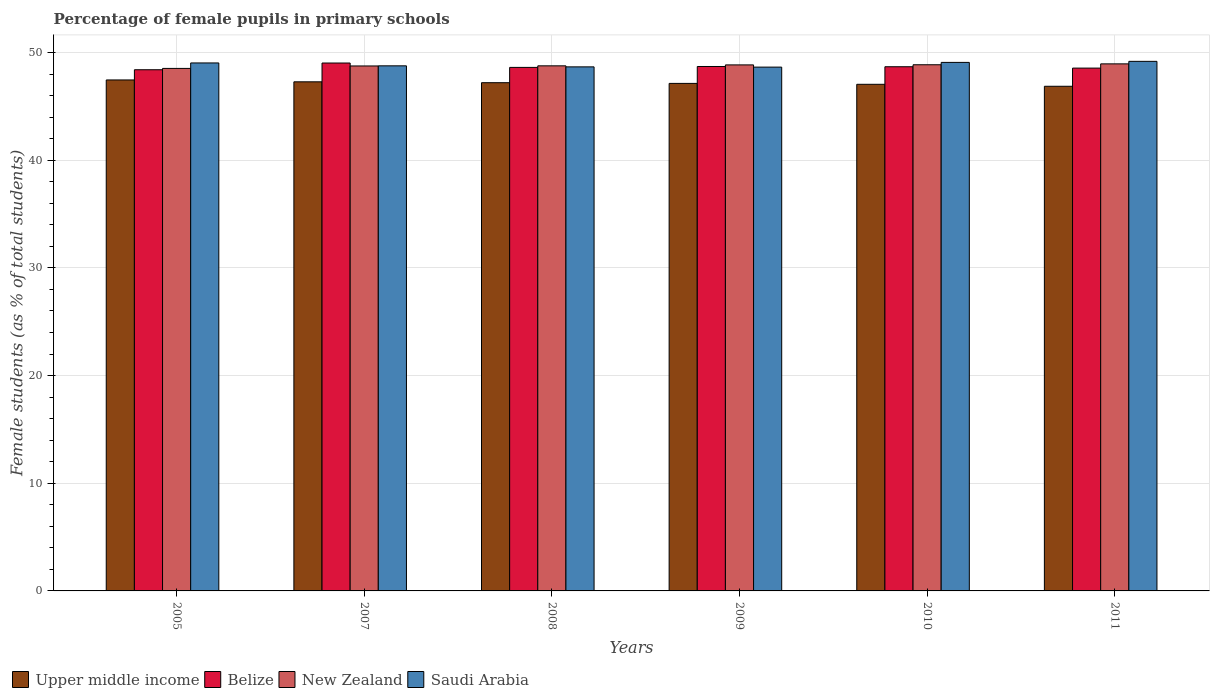Are the number of bars on each tick of the X-axis equal?
Give a very brief answer. Yes. How many bars are there on the 1st tick from the right?
Your response must be concise. 4. What is the label of the 5th group of bars from the left?
Keep it short and to the point. 2010. In how many cases, is the number of bars for a given year not equal to the number of legend labels?
Provide a short and direct response. 0. What is the percentage of female pupils in primary schools in New Zealand in 2008?
Your answer should be very brief. 48.76. Across all years, what is the maximum percentage of female pupils in primary schools in Saudi Arabia?
Your answer should be very brief. 49.18. Across all years, what is the minimum percentage of female pupils in primary schools in Saudi Arabia?
Make the answer very short. 48.64. In which year was the percentage of female pupils in primary schools in Saudi Arabia maximum?
Ensure brevity in your answer.  2011. What is the total percentage of female pupils in primary schools in Belize in the graph?
Ensure brevity in your answer.  291.96. What is the difference between the percentage of female pupils in primary schools in Saudi Arabia in 2009 and that in 2011?
Offer a terse response. -0.54. What is the difference between the percentage of female pupils in primary schools in Belize in 2011 and the percentage of female pupils in primary schools in Upper middle income in 2009?
Your answer should be compact. 1.42. What is the average percentage of female pupils in primary schools in Saudi Arabia per year?
Your answer should be very brief. 48.89. In the year 2009, what is the difference between the percentage of female pupils in primary schools in Upper middle income and percentage of female pupils in primary schools in Saudi Arabia?
Your answer should be compact. -1.51. What is the ratio of the percentage of female pupils in primary schools in Belize in 2005 to that in 2009?
Provide a succinct answer. 0.99. What is the difference between the highest and the second highest percentage of female pupils in primary schools in Saudi Arabia?
Offer a very short reply. 0.1. What is the difference between the highest and the lowest percentage of female pupils in primary schools in Upper middle income?
Your answer should be very brief. 0.59. In how many years, is the percentage of female pupils in primary schools in Saudi Arabia greater than the average percentage of female pupils in primary schools in Saudi Arabia taken over all years?
Provide a short and direct response. 3. What does the 4th bar from the left in 2005 represents?
Provide a short and direct response. Saudi Arabia. What does the 2nd bar from the right in 2009 represents?
Your response must be concise. New Zealand. Is it the case that in every year, the sum of the percentage of female pupils in primary schools in New Zealand and percentage of female pupils in primary schools in Belize is greater than the percentage of female pupils in primary schools in Upper middle income?
Provide a succinct answer. Yes. Are all the bars in the graph horizontal?
Your answer should be compact. No. How many legend labels are there?
Provide a short and direct response. 4. How are the legend labels stacked?
Your answer should be compact. Horizontal. What is the title of the graph?
Offer a terse response. Percentage of female pupils in primary schools. Does "Iceland" appear as one of the legend labels in the graph?
Your answer should be very brief. No. What is the label or title of the X-axis?
Give a very brief answer. Years. What is the label or title of the Y-axis?
Offer a very short reply. Female students (as % of total students). What is the Female students (as % of total students) of Upper middle income in 2005?
Your response must be concise. 47.45. What is the Female students (as % of total students) in Belize in 2005?
Offer a terse response. 48.4. What is the Female students (as % of total students) in New Zealand in 2005?
Offer a terse response. 48.52. What is the Female students (as % of total students) of Saudi Arabia in 2005?
Your response must be concise. 49.03. What is the Female students (as % of total students) in Upper middle income in 2007?
Ensure brevity in your answer.  47.28. What is the Female students (as % of total students) of Belize in 2007?
Offer a terse response. 49.02. What is the Female students (as % of total students) of New Zealand in 2007?
Offer a terse response. 48.75. What is the Female students (as % of total students) in Saudi Arabia in 2007?
Your answer should be very brief. 48.76. What is the Female students (as % of total students) of Upper middle income in 2008?
Keep it short and to the point. 47.19. What is the Female students (as % of total students) of Belize in 2008?
Ensure brevity in your answer.  48.62. What is the Female students (as % of total students) of New Zealand in 2008?
Offer a very short reply. 48.76. What is the Female students (as % of total students) in Saudi Arabia in 2008?
Your answer should be compact. 48.66. What is the Female students (as % of total students) of Upper middle income in 2009?
Your response must be concise. 47.13. What is the Female students (as % of total students) of Belize in 2009?
Offer a very short reply. 48.7. What is the Female students (as % of total students) of New Zealand in 2009?
Provide a succinct answer. 48.85. What is the Female students (as % of total students) in Saudi Arabia in 2009?
Keep it short and to the point. 48.64. What is the Female students (as % of total students) of Upper middle income in 2010?
Provide a succinct answer. 47.04. What is the Female students (as % of total students) in Belize in 2010?
Keep it short and to the point. 48.68. What is the Female students (as % of total students) in New Zealand in 2010?
Offer a terse response. 48.86. What is the Female students (as % of total students) of Saudi Arabia in 2010?
Offer a very short reply. 49.08. What is the Female students (as % of total students) in Upper middle income in 2011?
Your answer should be very brief. 46.86. What is the Female students (as % of total students) of Belize in 2011?
Your answer should be very brief. 48.55. What is the Female students (as % of total students) of New Zealand in 2011?
Provide a succinct answer. 48.94. What is the Female students (as % of total students) of Saudi Arabia in 2011?
Give a very brief answer. 49.18. Across all years, what is the maximum Female students (as % of total students) of Upper middle income?
Your response must be concise. 47.45. Across all years, what is the maximum Female students (as % of total students) of Belize?
Offer a terse response. 49.02. Across all years, what is the maximum Female students (as % of total students) of New Zealand?
Give a very brief answer. 48.94. Across all years, what is the maximum Female students (as % of total students) of Saudi Arabia?
Your answer should be very brief. 49.18. Across all years, what is the minimum Female students (as % of total students) of Upper middle income?
Offer a terse response. 46.86. Across all years, what is the minimum Female students (as % of total students) of Belize?
Provide a short and direct response. 48.4. Across all years, what is the minimum Female students (as % of total students) in New Zealand?
Your response must be concise. 48.52. Across all years, what is the minimum Female students (as % of total students) of Saudi Arabia?
Provide a short and direct response. 48.64. What is the total Female students (as % of total students) of Upper middle income in the graph?
Offer a very short reply. 282.95. What is the total Female students (as % of total students) in Belize in the graph?
Ensure brevity in your answer.  291.96. What is the total Female students (as % of total students) of New Zealand in the graph?
Provide a short and direct response. 292.68. What is the total Female students (as % of total students) of Saudi Arabia in the graph?
Offer a terse response. 293.35. What is the difference between the Female students (as % of total students) in Upper middle income in 2005 and that in 2007?
Give a very brief answer. 0.17. What is the difference between the Female students (as % of total students) in Belize in 2005 and that in 2007?
Keep it short and to the point. -0.62. What is the difference between the Female students (as % of total students) of New Zealand in 2005 and that in 2007?
Give a very brief answer. -0.23. What is the difference between the Female students (as % of total students) of Saudi Arabia in 2005 and that in 2007?
Keep it short and to the point. 0.27. What is the difference between the Female students (as % of total students) of Upper middle income in 2005 and that in 2008?
Ensure brevity in your answer.  0.25. What is the difference between the Female students (as % of total students) in Belize in 2005 and that in 2008?
Give a very brief answer. -0.22. What is the difference between the Female students (as % of total students) of New Zealand in 2005 and that in 2008?
Ensure brevity in your answer.  -0.24. What is the difference between the Female students (as % of total students) of Saudi Arabia in 2005 and that in 2008?
Your answer should be compact. 0.36. What is the difference between the Female students (as % of total students) of Upper middle income in 2005 and that in 2009?
Make the answer very short. 0.32. What is the difference between the Female students (as % of total students) in Belize in 2005 and that in 2009?
Your answer should be very brief. -0.3. What is the difference between the Female students (as % of total students) in New Zealand in 2005 and that in 2009?
Provide a short and direct response. -0.33. What is the difference between the Female students (as % of total students) of Saudi Arabia in 2005 and that in 2009?
Your answer should be compact. 0.39. What is the difference between the Female students (as % of total students) in Upper middle income in 2005 and that in 2010?
Offer a very short reply. 0.41. What is the difference between the Female students (as % of total students) of Belize in 2005 and that in 2010?
Offer a terse response. -0.28. What is the difference between the Female students (as % of total students) of New Zealand in 2005 and that in 2010?
Ensure brevity in your answer.  -0.34. What is the difference between the Female students (as % of total students) in Saudi Arabia in 2005 and that in 2010?
Offer a very short reply. -0.05. What is the difference between the Female students (as % of total students) of Upper middle income in 2005 and that in 2011?
Your answer should be very brief. 0.59. What is the difference between the Female students (as % of total students) of Belize in 2005 and that in 2011?
Provide a succinct answer. -0.15. What is the difference between the Female students (as % of total students) in New Zealand in 2005 and that in 2011?
Your answer should be compact. -0.42. What is the difference between the Female students (as % of total students) in Saudi Arabia in 2005 and that in 2011?
Your answer should be compact. -0.15. What is the difference between the Female students (as % of total students) of Upper middle income in 2007 and that in 2008?
Make the answer very short. 0.08. What is the difference between the Female students (as % of total students) in Belize in 2007 and that in 2008?
Offer a terse response. 0.41. What is the difference between the Female students (as % of total students) of New Zealand in 2007 and that in 2008?
Offer a terse response. -0.01. What is the difference between the Female students (as % of total students) of Saudi Arabia in 2007 and that in 2008?
Your answer should be very brief. 0.1. What is the difference between the Female students (as % of total students) of Upper middle income in 2007 and that in 2009?
Ensure brevity in your answer.  0.15. What is the difference between the Female students (as % of total students) of Belize in 2007 and that in 2009?
Give a very brief answer. 0.32. What is the difference between the Female students (as % of total students) in New Zealand in 2007 and that in 2009?
Your response must be concise. -0.1. What is the difference between the Female students (as % of total students) in Saudi Arabia in 2007 and that in 2009?
Provide a succinct answer. 0.12. What is the difference between the Female students (as % of total students) of Upper middle income in 2007 and that in 2010?
Give a very brief answer. 0.23. What is the difference between the Female students (as % of total students) of Belize in 2007 and that in 2010?
Make the answer very short. 0.34. What is the difference between the Female students (as % of total students) of New Zealand in 2007 and that in 2010?
Give a very brief answer. -0.11. What is the difference between the Female students (as % of total students) of Saudi Arabia in 2007 and that in 2010?
Offer a very short reply. -0.32. What is the difference between the Female students (as % of total students) in Upper middle income in 2007 and that in 2011?
Offer a very short reply. 0.41. What is the difference between the Female students (as % of total students) of Belize in 2007 and that in 2011?
Keep it short and to the point. 0.47. What is the difference between the Female students (as % of total students) in New Zealand in 2007 and that in 2011?
Offer a terse response. -0.19. What is the difference between the Female students (as % of total students) in Saudi Arabia in 2007 and that in 2011?
Provide a short and direct response. -0.42. What is the difference between the Female students (as % of total students) of Upper middle income in 2008 and that in 2009?
Provide a succinct answer. 0.07. What is the difference between the Female students (as % of total students) in Belize in 2008 and that in 2009?
Make the answer very short. -0.08. What is the difference between the Female students (as % of total students) in New Zealand in 2008 and that in 2009?
Ensure brevity in your answer.  -0.09. What is the difference between the Female students (as % of total students) in Saudi Arabia in 2008 and that in 2009?
Provide a short and direct response. 0.02. What is the difference between the Female students (as % of total students) of Upper middle income in 2008 and that in 2010?
Provide a succinct answer. 0.15. What is the difference between the Female students (as % of total students) in Belize in 2008 and that in 2010?
Make the answer very short. -0.06. What is the difference between the Female students (as % of total students) in New Zealand in 2008 and that in 2010?
Your answer should be very brief. -0.1. What is the difference between the Female students (as % of total students) in Saudi Arabia in 2008 and that in 2010?
Ensure brevity in your answer.  -0.42. What is the difference between the Female students (as % of total students) in Upper middle income in 2008 and that in 2011?
Ensure brevity in your answer.  0.33. What is the difference between the Female students (as % of total students) of Belize in 2008 and that in 2011?
Your answer should be compact. 0.07. What is the difference between the Female students (as % of total students) of New Zealand in 2008 and that in 2011?
Your response must be concise. -0.18. What is the difference between the Female students (as % of total students) of Saudi Arabia in 2008 and that in 2011?
Provide a succinct answer. -0.51. What is the difference between the Female students (as % of total students) in Upper middle income in 2009 and that in 2010?
Make the answer very short. 0.08. What is the difference between the Female students (as % of total students) of Belize in 2009 and that in 2010?
Provide a succinct answer. 0.02. What is the difference between the Female students (as % of total students) of New Zealand in 2009 and that in 2010?
Ensure brevity in your answer.  -0.01. What is the difference between the Female students (as % of total students) of Saudi Arabia in 2009 and that in 2010?
Keep it short and to the point. -0.44. What is the difference between the Female students (as % of total students) of Upper middle income in 2009 and that in 2011?
Your answer should be very brief. 0.27. What is the difference between the Female students (as % of total students) in Belize in 2009 and that in 2011?
Your answer should be compact. 0.15. What is the difference between the Female students (as % of total students) of New Zealand in 2009 and that in 2011?
Give a very brief answer. -0.1. What is the difference between the Female students (as % of total students) of Saudi Arabia in 2009 and that in 2011?
Offer a very short reply. -0.54. What is the difference between the Female students (as % of total students) in Upper middle income in 2010 and that in 2011?
Ensure brevity in your answer.  0.18. What is the difference between the Female students (as % of total students) of Belize in 2010 and that in 2011?
Provide a short and direct response. 0.13. What is the difference between the Female students (as % of total students) of New Zealand in 2010 and that in 2011?
Offer a terse response. -0.08. What is the difference between the Female students (as % of total students) in Saudi Arabia in 2010 and that in 2011?
Provide a short and direct response. -0.1. What is the difference between the Female students (as % of total students) in Upper middle income in 2005 and the Female students (as % of total students) in Belize in 2007?
Keep it short and to the point. -1.57. What is the difference between the Female students (as % of total students) of Upper middle income in 2005 and the Female students (as % of total students) of New Zealand in 2007?
Offer a terse response. -1.3. What is the difference between the Female students (as % of total students) in Upper middle income in 2005 and the Female students (as % of total students) in Saudi Arabia in 2007?
Ensure brevity in your answer.  -1.31. What is the difference between the Female students (as % of total students) of Belize in 2005 and the Female students (as % of total students) of New Zealand in 2007?
Ensure brevity in your answer.  -0.35. What is the difference between the Female students (as % of total students) of Belize in 2005 and the Female students (as % of total students) of Saudi Arabia in 2007?
Ensure brevity in your answer.  -0.36. What is the difference between the Female students (as % of total students) of New Zealand in 2005 and the Female students (as % of total students) of Saudi Arabia in 2007?
Your answer should be very brief. -0.24. What is the difference between the Female students (as % of total students) in Upper middle income in 2005 and the Female students (as % of total students) in Belize in 2008?
Your answer should be compact. -1.17. What is the difference between the Female students (as % of total students) in Upper middle income in 2005 and the Female students (as % of total students) in New Zealand in 2008?
Offer a very short reply. -1.31. What is the difference between the Female students (as % of total students) of Upper middle income in 2005 and the Female students (as % of total students) of Saudi Arabia in 2008?
Offer a very short reply. -1.21. What is the difference between the Female students (as % of total students) of Belize in 2005 and the Female students (as % of total students) of New Zealand in 2008?
Keep it short and to the point. -0.36. What is the difference between the Female students (as % of total students) in Belize in 2005 and the Female students (as % of total students) in Saudi Arabia in 2008?
Give a very brief answer. -0.27. What is the difference between the Female students (as % of total students) of New Zealand in 2005 and the Female students (as % of total students) of Saudi Arabia in 2008?
Your answer should be very brief. -0.14. What is the difference between the Female students (as % of total students) in Upper middle income in 2005 and the Female students (as % of total students) in Belize in 2009?
Ensure brevity in your answer.  -1.25. What is the difference between the Female students (as % of total students) of Upper middle income in 2005 and the Female students (as % of total students) of New Zealand in 2009?
Make the answer very short. -1.4. What is the difference between the Female students (as % of total students) in Upper middle income in 2005 and the Female students (as % of total students) in Saudi Arabia in 2009?
Offer a terse response. -1.19. What is the difference between the Female students (as % of total students) of Belize in 2005 and the Female students (as % of total students) of New Zealand in 2009?
Your answer should be compact. -0.45. What is the difference between the Female students (as % of total students) of Belize in 2005 and the Female students (as % of total students) of Saudi Arabia in 2009?
Your answer should be very brief. -0.24. What is the difference between the Female students (as % of total students) of New Zealand in 2005 and the Female students (as % of total students) of Saudi Arabia in 2009?
Make the answer very short. -0.12. What is the difference between the Female students (as % of total students) in Upper middle income in 2005 and the Female students (as % of total students) in Belize in 2010?
Offer a terse response. -1.23. What is the difference between the Female students (as % of total students) of Upper middle income in 2005 and the Female students (as % of total students) of New Zealand in 2010?
Offer a very short reply. -1.41. What is the difference between the Female students (as % of total students) in Upper middle income in 2005 and the Female students (as % of total students) in Saudi Arabia in 2010?
Make the answer very short. -1.63. What is the difference between the Female students (as % of total students) in Belize in 2005 and the Female students (as % of total students) in New Zealand in 2010?
Provide a short and direct response. -0.46. What is the difference between the Female students (as % of total students) of Belize in 2005 and the Female students (as % of total students) of Saudi Arabia in 2010?
Offer a terse response. -0.68. What is the difference between the Female students (as % of total students) of New Zealand in 2005 and the Female students (as % of total students) of Saudi Arabia in 2010?
Offer a very short reply. -0.56. What is the difference between the Female students (as % of total students) in Upper middle income in 2005 and the Female students (as % of total students) in Belize in 2011?
Your answer should be compact. -1.1. What is the difference between the Female students (as % of total students) of Upper middle income in 2005 and the Female students (as % of total students) of New Zealand in 2011?
Give a very brief answer. -1.49. What is the difference between the Female students (as % of total students) in Upper middle income in 2005 and the Female students (as % of total students) in Saudi Arabia in 2011?
Provide a short and direct response. -1.73. What is the difference between the Female students (as % of total students) in Belize in 2005 and the Female students (as % of total students) in New Zealand in 2011?
Provide a short and direct response. -0.55. What is the difference between the Female students (as % of total students) in Belize in 2005 and the Female students (as % of total students) in Saudi Arabia in 2011?
Your answer should be very brief. -0.78. What is the difference between the Female students (as % of total students) of New Zealand in 2005 and the Female students (as % of total students) of Saudi Arabia in 2011?
Provide a short and direct response. -0.66. What is the difference between the Female students (as % of total students) in Upper middle income in 2007 and the Female students (as % of total students) in Belize in 2008?
Provide a short and direct response. -1.34. What is the difference between the Female students (as % of total students) of Upper middle income in 2007 and the Female students (as % of total students) of New Zealand in 2008?
Make the answer very short. -1.48. What is the difference between the Female students (as % of total students) in Upper middle income in 2007 and the Female students (as % of total students) in Saudi Arabia in 2008?
Your answer should be very brief. -1.39. What is the difference between the Female students (as % of total students) in Belize in 2007 and the Female students (as % of total students) in New Zealand in 2008?
Provide a succinct answer. 0.26. What is the difference between the Female students (as % of total students) in Belize in 2007 and the Female students (as % of total students) in Saudi Arabia in 2008?
Offer a terse response. 0.36. What is the difference between the Female students (as % of total students) of New Zealand in 2007 and the Female students (as % of total students) of Saudi Arabia in 2008?
Give a very brief answer. 0.08. What is the difference between the Female students (as % of total students) in Upper middle income in 2007 and the Female students (as % of total students) in Belize in 2009?
Ensure brevity in your answer.  -1.42. What is the difference between the Female students (as % of total students) of Upper middle income in 2007 and the Female students (as % of total students) of New Zealand in 2009?
Make the answer very short. -1.57. What is the difference between the Female students (as % of total students) of Upper middle income in 2007 and the Female students (as % of total students) of Saudi Arabia in 2009?
Your answer should be compact. -1.37. What is the difference between the Female students (as % of total students) of Belize in 2007 and the Female students (as % of total students) of New Zealand in 2009?
Make the answer very short. 0.17. What is the difference between the Female students (as % of total students) in Belize in 2007 and the Female students (as % of total students) in Saudi Arabia in 2009?
Offer a terse response. 0.38. What is the difference between the Female students (as % of total students) in New Zealand in 2007 and the Female students (as % of total students) in Saudi Arabia in 2009?
Keep it short and to the point. 0.11. What is the difference between the Female students (as % of total students) in Upper middle income in 2007 and the Female students (as % of total students) in Belize in 2010?
Make the answer very short. -1.4. What is the difference between the Female students (as % of total students) of Upper middle income in 2007 and the Female students (as % of total students) of New Zealand in 2010?
Keep it short and to the point. -1.59. What is the difference between the Female students (as % of total students) of Upper middle income in 2007 and the Female students (as % of total students) of Saudi Arabia in 2010?
Give a very brief answer. -1.8. What is the difference between the Female students (as % of total students) in Belize in 2007 and the Female students (as % of total students) in New Zealand in 2010?
Offer a terse response. 0.16. What is the difference between the Female students (as % of total students) of Belize in 2007 and the Female students (as % of total students) of Saudi Arabia in 2010?
Your response must be concise. -0.06. What is the difference between the Female students (as % of total students) of New Zealand in 2007 and the Female students (as % of total students) of Saudi Arabia in 2010?
Offer a very short reply. -0.33. What is the difference between the Female students (as % of total students) in Upper middle income in 2007 and the Female students (as % of total students) in Belize in 2011?
Give a very brief answer. -1.27. What is the difference between the Female students (as % of total students) in Upper middle income in 2007 and the Female students (as % of total students) in New Zealand in 2011?
Provide a succinct answer. -1.67. What is the difference between the Female students (as % of total students) of Upper middle income in 2007 and the Female students (as % of total students) of Saudi Arabia in 2011?
Your response must be concise. -1.9. What is the difference between the Female students (as % of total students) in Belize in 2007 and the Female students (as % of total students) in New Zealand in 2011?
Your answer should be very brief. 0.08. What is the difference between the Female students (as % of total students) of Belize in 2007 and the Female students (as % of total students) of Saudi Arabia in 2011?
Offer a very short reply. -0.15. What is the difference between the Female students (as % of total students) in New Zealand in 2007 and the Female students (as % of total students) in Saudi Arabia in 2011?
Make the answer very short. -0.43. What is the difference between the Female students (as % of total students) of Upper middle income in 2008 and the Female students (as % of total students) of Belize in 2009?
Make the answer very short. -1.5. What is the difference between the Female students (as % of total students) of Upper middle income in 2008 and the Female students (as % of total students) of New Zealand in 2009?
Offer a terse response. -1.65. What is the difference between the Female students (as % of total students) in Upper middle income in 2008 and the Female students (as % of total students) in Saudi Arabia in 2009?
Your answer should be compact. -1.45. What is the difference between the Female students (as % of total students) of Belize in 2008 and the Female students (as % of total students) of New Zealand in 2009?
Keep it short and to the point. -0.23. What is the difference between the Female students (as % of total students) in Belize in 2008 and the Female students (as % of total students) in Saudi Arabia in 2009?
Your response must be concise. -0.03. What is the difference between the Female students (as % of total students) in New Zealand in 2008 and the Female students (as % of total students) in Saudi Arabia in 2009?
Give a very brief answer. 0.12. What is the difference between the Female students (as % of total students) in Upper middle income in 2008 and the Female students (as % of total students) in Belize in 2010?
Offer a very short reply. -1.48. What is the difference between the Female students (as % of total students) in Upper middle income in 2008 and the Female students (as % of total students) in New Zealand in 2010?
Provide a succinct answer. -1.67. What is the difference between the Female students (as % of total students) of Upper middle income in 2008 and the Female students (as % of total students) of Saudi Arabia in 2010?
Give a very brief answer. -1.88. What is the difference between the Female students (as % of total students) of Belize in 2008 and the Female students (as % of total students) of New Zealand in 2010?
Ensure brevity in your answer.  -0.25. What is the difference between the Female students (as % of total students) of Belize in 2008 and the Female students (as % of total students) of Saudi Arabia in 2010?
Provide a succinct answer. -0.46. What is the difference between the Female students (as % of total students) in New Zealand in 2008 and the Female students (as % of total students) in Saudi Arabia in 2010?
Keep it short and to the point. -0.32. What is the difference between the Female students (as % of total students) of Upper middle income in 2008 and the Female students (as % of total students) of Belize in 2011?
Keep it short and to the point. -1.35. What is the difference between the Female students (as % of total students) of Upper middle income in 2008 and the Female students (as % of total students) of New Zealand in 2011?
Give a very brief answer. -1.75. What is the difference between the Female students (as % of total students) in Upper middle income in 2008 and the Female students (as % of total students) in Saudi Arabia in 2011?
Your response must be concise. -1.98. What is the difference between the Female students (as % of total students) of Belize in 2008 and the Female students (as % of total students) of New Zealand in 2011?
Your response must be concise. -0.33. What is the difference between the Female students (as % of total students) in Belize in 2008 and the Female students (as % of total students) in Saudi Arabia in 2011?
Your answer should be compact. -0.56. What is the difference between the Female students (as % of total students) in New Zealand in 2008 and the Female students (as % of total students) in Saudi Arabia in 2011?
Offer a terse response. -0.42. What is the difference between the Female students (as % of total students) of Upper middle income in 2009 and the Female students (as % of total students) of Belize in 2010?
Keep it short and to the point. -1.55. What is the difference between the Female students (as % of total students) in Upper middle income in 2009 and the Female students (as % of total students) in New Zealand in 2010?
Make the answer very short. -1.73. What is the difference between the Female students (as % of total students) of Upper middle income in 2009 and the Female students (as % of total students) of Saudi Arabia in 2010?
Your answer should be compact. -1.95. What is the difference between the Female students (as % of total students) of Belize in 2009 and the Female students (as % of total students) of New Zealand in 2010?
Make the answer very short. -0.16. What is the difference between the Female students (as % of total students) of Belize in 2009 and the Female students (as % of total students) of Saudi Arabia in 2010?
Offer a terse response. -0.38. What is the difference between the Female students (as % of total students) in New Zealand in 2009 and the Female students (as % of total students) in Saudi Arabia in 2010?
Offer a very short reply. -0.23. What is the difference between the Female students (as % of total students) in Upper middle income in 2009 and the Female students (as % of total students) in Belize in 2011?
Provide a short and direct response. -1.42. What is the difference between the Female students (as % of total students) in Upper middle income in 2009 and the Female students (as % of total students) in New Zealand in 2011?
Your answer should be compact. -1.81. What is the difference between the Female students (as % of total students) in Upper middle income in 2009 and the Female students (as % of total students) in Saudi Arabia in 2011?
Keep it short and to the point. -2.05. What is the difference between the Female students (as % of total students) in Belize in 2009 and the Female students (as % of total students) in New Zealand in 2011?
Your answer should be compact. -0.24. What is the difference between the Female students (as % of total students) of Belize in 2009 and the Female students (as % of total students) of Saudi Arabia in 2011?
Offer a very short reply. -0.48. What is the difference between the Female students (as % of total students) in New Zealand in 2009 and the Female students (as % of total students) in Saudi Arabia in 2011?
Your answer should be very brief. -0.33. What is the difference between the Female students (as % of total students) in Upper middle income in 2010 and the Female students (as % of total students) in Belize in 2011?
Offer a terse response. -1.51. What is the difference between the Female students (as % of total students) of Upper middle income in 2010 and the Female students (as % of total students) of New Zealand in 2011?
Give a very brief answer. -1.9. What is the difference between the Female students (as % of total students) of Upper middle income in 2010 and the Female students (as % of total students) of Saudi Arabia in 2011?
Your response must be concise. -2.13. What is the difference between the Female students (as % of total students) in Belize in 2010 and the Female students (as % of total students) in New Zealand in 2011?
Your answer should be compact. -0.27. What is the difference between the Female students (as % of total students) of Belize in 2010 and the Female students (as % of total students) of Saudi Arabia in 2011?
Keep it short and to the point. -0.5. What is the difference between the Female students (as % of total students) in New Zealand in 2010 and the Female students (as % of total students) in Saudi Arabia in 2011?
Ensure brevity in your answer.  -0.32. What is the average Female students (as % of total students) in Upper middle income per year?
Your answer should be very brief. 47.16. What is the average Female students (as % of total students) of Belize per year?
Provide a succinct answer. 48.66. What is the average Female students (as % of total students) in New Zealand per year?
Ensure brevity in your answer.  48.78. What is the average Female students (as % of total students) in Saudi Arabia per year?
Offer a terse response. 48.89. In the year 2005, what is the difference between the Female students (as % of total students) of Upper middle income and Female students (as % of total students) of Belize?
Make the answer very short. -0.95. In the year 2005, what is the difference between the Female students (as % of total students) of Upper middle income and Female students (as % of total students) of New Zealand?
Provide a short and direct response. -1.07. In the year 2005, what is the difference between the Female students (as % of total students) of Upper middle income and Female students (as % of total students) of Saudi Arabia?
Offer a terse response. -1.58. In the year 2005, what is the difference between the Female students (as % of total students) of Belize and Female students (as % of total students) of New Zealand?
Give a very brief answer. -0.12. In the year 2005, what is the difference between the Female students (as % of total students) of Belize and Female students (as % of total students) of Saudi Arabia?
Your answer should be compact. -0.63. In the year 2005, what is the difference between the Female students (as % of total students) of New Zealand and Female students (as % of total students) of Saudi Arabia?
Provide a short and direct response. -0.51. In the year 2007, what is the difference between the Female students (as % of total students) of Upper middle income and Female students (as % of total students) of Belize?
Keep it short and to the point. -1.75. In the year 2007, what is the difference between the Female students (as % of total students) in Upper middle income and Female students (as % of total students) in New Zealand?
Keep it short and to the point. -1.47. In the year 2007, what is the difference between the Female students (as % of total students) in Upper middle income and Female students (as % of total students) in Saudi Arabia?
Provide a short and direct response. -1.48. In the year 2007, what is the difference between the Female students (as % of total students) of Belize and Female students (as % of total students) of New Zealand?
Give a very brief answer. 0.27. In the year 2007, what is the difference between the Female students (as % of total students) in Belize and Female students (as % of total students) in Saudi Arabia?
Offer a terse response. 0.26. In the year 2007, what is the difference between the Female students (as % of total students) in New Zealand and Female students (as % of total students) in Saudi Arabia?
Your answer should be compact. -0.01. In the year 2008, what is the difference between the Female students (as % of total students) of Upper middle income and Female students (as % of total students) of Belize?
Provide a short and direct response. -1.42. In the year 2008, what is the difference between the Female students (as % of total students) in Upper middle income and Female students (as % of total students) in New Zealand?
Give a very brief answer. -1.57. In the year 2008, what is the difference between the Female students (as % of total students) of Upper middle income and Female students (as % of total students) of Saudi Arabia?
Give a very brief answer. -1.47. In the year 2008, what is the difference between the Female students (as % of total students) of Belize and Female students (as % of total students) of New Zealand?
Provide a succinct answer. -0.14. In the year 2008, what is the difference between the Female students (as % of total students) of Belize and Female students (as % of total students) of Saudi Arabia?
Offer a very short reply. -0.05. In the year 2008, what is the difference between the Female students (as % of total students) in New Zealand and Female students (as % of total students) in Saudi Arabia?
Provide a succinct answer. 0.1. In the year 2009, what is the difference between the Female students (as % of total students) in Upper middle income and Female students (as % of total students) in Belize?
Your response must be concise. -1.57. In the year 2009, what is the difference between the Female students (as % of total students) in Upper middle income and Female students (as % of total students) in New Zealand?
Provide a short and direct response. -1.72. In the year 2009, what is the difference between the Female students (as % of total students) of Upper middle income and Female students (as % of total students) of Saudi Arabia?
Your response must be concise. -1.51. In the year 2009, what is the difference between the Female students (as % of total students) in Belize and Female students (as % of total students) in New Zealand?
Your response must be concise. -0.15. In the year 2009, what is the difference between the Female students (as % of total students) of Belize and Female students (as % of total students) of Saudi Arabia?
Offer a very short reply. 0.06. In the year 2009, what is the difference between the Female students (as % of total students) of New Zealand and Female students (as % of total students) of Saudi Arabia?
Offer a very short reply. 0.21. In the year 2010, what is the difference between the Female students (as % of total students) in Upper middle income and Female students (as % of total students) in Belize?
Provide a short and direct response. -1.63. In the year 2010, what is the difference between the Female students (as % of total students) of Upper middle income and Female students (as % of total students) of New Zealand?
Offer a very short reply. -1.82. In the year 2010, what is the difference between the Female students (as % of total students) of Upper middle income and Female students (as % of total students) of Saudi Arabia?
Offer a very short reply. -2.04. In the year 2010, what is the difference between the Female students (as % of total students) in Belize and Female students (as % of total students) in New Zealand?
Make the answer very short. -0.18. In the year 2010, what is the difference between the Female students (as % of total students) in Belize and Female students (as % of total students) in Saudi Arabia?
Provide a short and direct response. -0.4. In the year 2010, what is the difference between the Female students (as % of total students) of New Zealand and Female students (as % of total students) of Saudi Arabia?
Offer a terse response. -0.22. In the year 2011, what is the difference between the Female students (as % of total students) in Upper middle income and Female students (as % of total students) in Belize?
Your response must be concise. -1.69. In the year 2011, what is the difference between the Female students (as % of total students) of Upper middle income and Female students (as % of total students) of New Zealand?
Make the answer very short. -2.08. In the year 2011, what is the difference between the Female students (as % of total students) in Upper middle income and Female students (as % of total students) in Saudi Arabia?
Keep it short and to the point. -2.31. In the year 2011, what is the difference between the Female students (as % of total students) of Belize and Female students (as % of total students) of New Zealand?
Your response must be concise. -0.39. In the year 2011, what is the difference between the Female students (as % of total students) in Belize and Female students (as % of total students) in Saudi Arabia?
Give a very brief answer. -0.63. In the year 2011, what is the difference between the Female students (as % of total students) in New Zealand and Female students (as % of total students) in Saudi Arabia?
Provide a short and direct response. -0.23. What is the ratio of the Female students (as % of total students) of Upper middle income in 2005 to that in 2007?
Your answer should be very brief. 1. What is the ratio of the Female students (as % of total students) in Belize in 2005 to that in 2007?
Ensure brevity in your answer.  0.99. What is the ratio of the Female students (as % of total students) of Saudi Arabia in 2005 to that in 2007?
Provide a succinct answer. 1.01. What is the ratio of the Female students (as % of total students) in Upper middle income in 2005 to that in 2008?
Make the answer very short. 1.01. What is the ratio of the Female students (as % of total students) in New Zealand in 2005 to that in 2008?
Offer a very short reply. 1. What is the ratio of the Female students (as % of total students) in Saudi Arabia in 2005 to that in 2008?
Your response must be concise. 1.01. What is the ratio of the Female students (as % of total students) in Upper middle income in 2005 to that in 2009?
Provide a succinct answer. 1.01. What is the ratio of the Female students (as % of total students) of Belize in 2005 to that in 2009?
Make the answer very short. 0.99. What is the ratio of the Female students (as % of total students) of Saudi Arabia in 2005 to that in 2009?
Give a very brief answer. 1.01. What is the ratio of the Female students (as % of total students) of Upper middle income in 2005 to that in 2010?
Provide a short and direct response. 1.01. What is the ratio of the Female students (as % of total students) of Belize in 2005 to that in 2010?
Provide a succinct answer. 0.99. What is the ratio of the Female students (as % of total students) of New Zealand in 2005 to that in 2010?
Offer a terse response. 0.99. What is the ratio of the Female students (as % of total students) in Saudi Arabia in 2005 to that in 2010?
Provide a short and direct response. 1. What is the ratio of the Female students (as % of total students) of Upper middle income in 2005 to that in 2011?
Offer a very short reply. 1.01. What is the ratio of the Female students (as % of total students) of Upper middle income in 2007 to that in 2008?
Offer a very short reply. 1. What is the ratio of the Female students (as % of total students) in Belize in 2007 to that in 2008?
Give a very brief answer. 1.01. What is the ratio of the Female students (as % of total students) in Saudi Arabia in 2007 to that in 2008?
Provide a succinct answer. 1. What is the ratio of the Female students (as % of total students) in Upper middle income in 2007 to that in 2009?
Make the answer very short. 1. What is the ratio of the Female students (as % of total students) of Belize in 2007 to that in 2009?
Keep it short and to the point. 1.01. What is the ratio of the Female students (as % of total students) of New Zealand in 2007 to that in 2009?
Your answer should be compact. 1. What is the ratio of the Female students (as % of total students) of Upper middle income in 2007 to that in 2010?
Keep it short and to the point. 1. What is the ratio of the Female students (as % of total students) in Belize in 2007 to that in 2010?
Offer a very short reply. 1.01. What is the ratio of the Female students (as % of total students) in New Zealand in 2007 to that in 2010?
Make the answer very short. 1. What is the ratio of the Female students (as % of total students) of Upper middle income in 2007 to that in 2011?
Give a very brief answer. 1.01. What is the ratio of the Female students (as % of total students) in Belize in 2007 to that in 2011?
Your answer should be very brief. 1.01. What is the ratio of the Female students (as % of total students) of Saudi Arabia in 2007 to that in 2011?
Offer a very short reply. 0.99. What is the ratio of the Female students (as % of total students) in Upper middle income in 2008 to that in 2009?
Make the answer very short. 1. What is the ratio of the Female students (as % of total students) of Belize in 2008 to that in 2009?
Provide a succinct answer. 1. What is the ratio of the Female students (as % of total students) of Upper middle income in 2008 to that in 2010?
Offer a very short reply. 1. What is the ratio of the Female students (as % of total students) of Belize in 2008 to that in 2010?
Keep it short and to the point. 1. What is the ratio of the Female students (as % of total students) of New Zealand in 2008 to that in 2010?
Give a very brief answer. 1. What is the ratio of the Female students (as % of total students) of Saudi Arabia in 2008 to that in 2010?
Your answer should be very brief. 0.99. What is the ratio of the Female students (as % of total students) of Upper middle income in 2008 to that in 2011?
Your answer should be very brief. 1.01. What is the ratio of the Female students (as % of total students) in New Zealand in 2008 to that in 2011?
Keep it short and to the point. 1. What is the ratio of the Female students (as % of total students) in Upper middle income in 2009 to that in 2010?
Keep it short and to the point. 1. What is the ratio of the Female students (as % of total students) in Belize in 2009 to that in 2010?
Give a very brief answer. 1. What is the ratio of the Female students (as % of total students) of New Zealand in 2009 to that in 2010?
Your response must be concise. 1. What is the ratio of the Female students (as % of total students) of Saudi Arabia in 2009 to that in 2010?
Your answer should be compact. 0.99. What is the ratio of the Female students (as % of total students) of Upper middle income in 2010 to that in 2011?
Keep it short and to the point. 1. What is the ratio of the Female students (as % of total students) of New Zealand in 2010 to that in 2011?
Provide a succinct answer. 1. What is the ratio of the Female students (as % of total students) in Saudi Arabia in 2010 to that in 2011?
Make the answer very short. 1. What is the difference between the highest and the second highest Female students (as % of total students) of Upper middle income?
Provide a succinct answer. 0.17. What is the difference between the highest and the second highest Female students (as % of total students) of Belize?
Your answer should be very brief. 0.32. What is the difference between the highest and the second highest Female students (as % of total students) of New Zealand?
Provide a short and direct response. 0.08. What is the difference between the highest and the second highest Female students (as % of total students) of Saudi Arabia?
Keep it short and to the point. 0.1. What is the difference between the highest and the lowest Female students (as % of total students) of Upper middle income?
Offer a terse response. 0.59. What is the difference between the highest and the lowest Female students (as % of total students) of Belize?
Provide a succinct answer. 0.62. What is the difference between the highest and the lowest Female students (as % of total students) of New Zealand?
Your answer should be very brief. 0.42. What is the difference between the highest and the lowest Female students (as % of total students) in Saudi Arabia?
Provide a short and direct response. 0.54. 